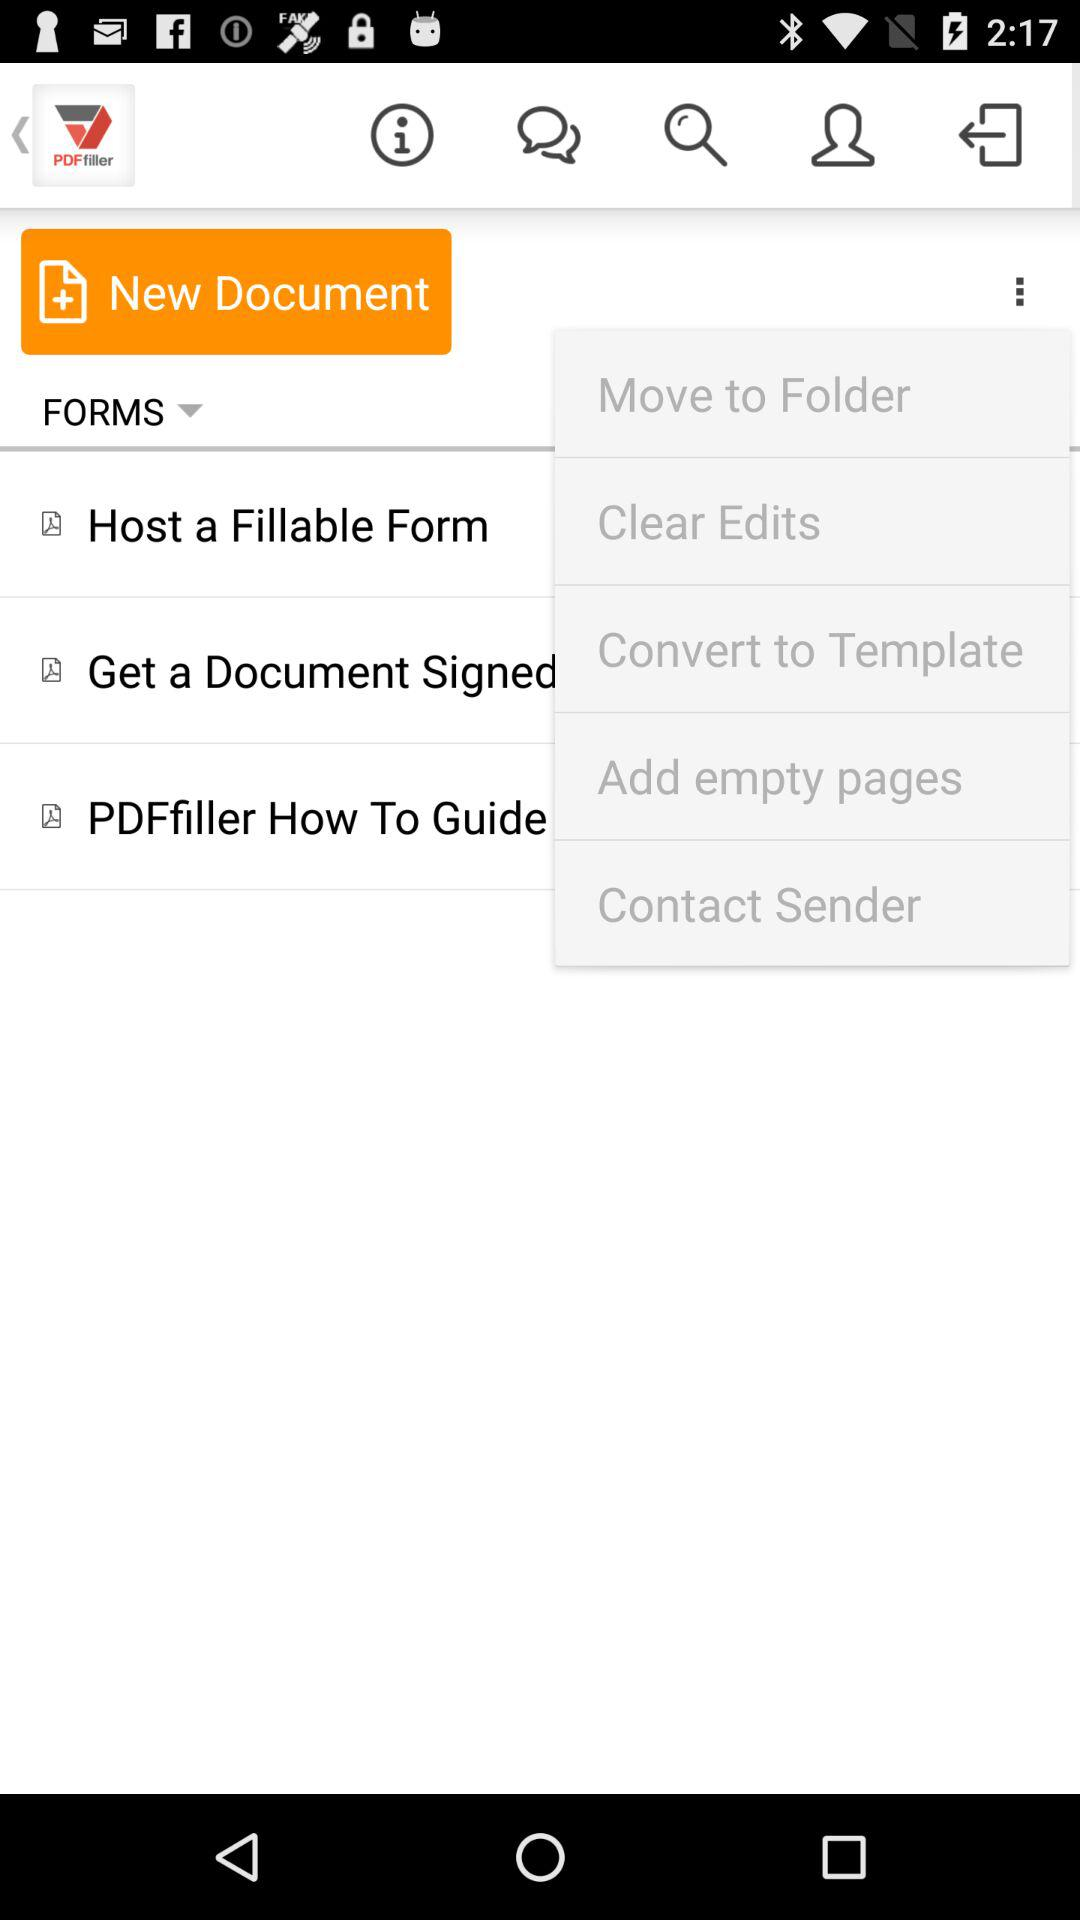What is the name of the application? The name of the application is "PDF filler". 